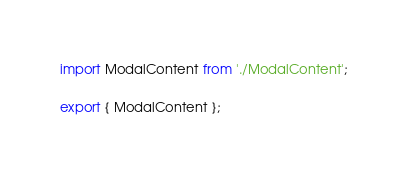<code> <loc_0><loc_0><loc_500><loc_500><_TypeScript_>import ModalContent from './ModalContent';

export { ModalContent };
</code> 